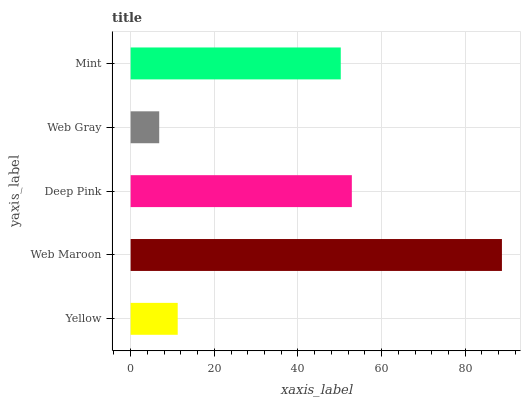Is Web Gray the minimum?
Answer yes or no. Yes. Is Web Maroon the maximum?
Answer yes or no. Yes. Is Deep Pink the minimum?
Answer yes or no. No. Is Deep Pink the maximum?
Answer yes or no. No. Is Web Maroon greater than Deep Pink?
Answer yes or no. Yes. Is Deep Pink less than Web Maroon?
Answer yes or no. Yes. Is Deep Pink greater than Web Maroon?
Answer yes or no. No. Is Web Maroon less than Deep Pink?
Answer yes or no. No. Is Mint the high median?
Answer yes or no. Yes. Is Mint the low median?
Answer yes or no. Yes. Is Deep Pink the high median?
Answer yes or no. No. Is Web Maroon the low median?
Answer yes or no. No. 